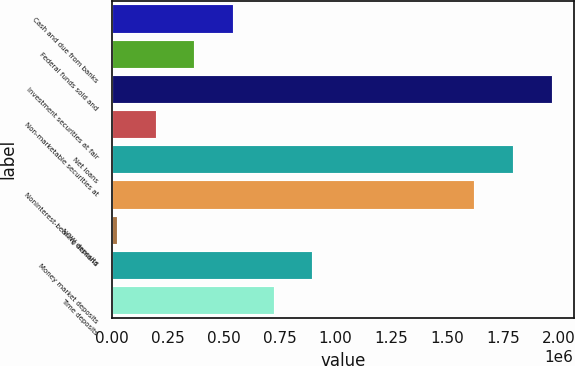Convert chart to OTSL. <chart><loc_0><loc_0><loc_500><loc_500><bar_chart><fcel>Cash and due from banks<fcel>Federal funds sold and<fcel>Investment securities at fair<fcel>Non-marketable securities at<fcel>Net loans<fcel>Noninterest-bearing demand<fcel>NOW deposits<fcel>Money market deposits<fcel>Time deposits<nl><fcel>542808<fcel>368788<fcel>1.96718e+06<fcel>194769<fcel>1.79316e+06<fcel>1.61914e+06<fcel>20750<fcel>896906<fcel>722887<nl></chart> 